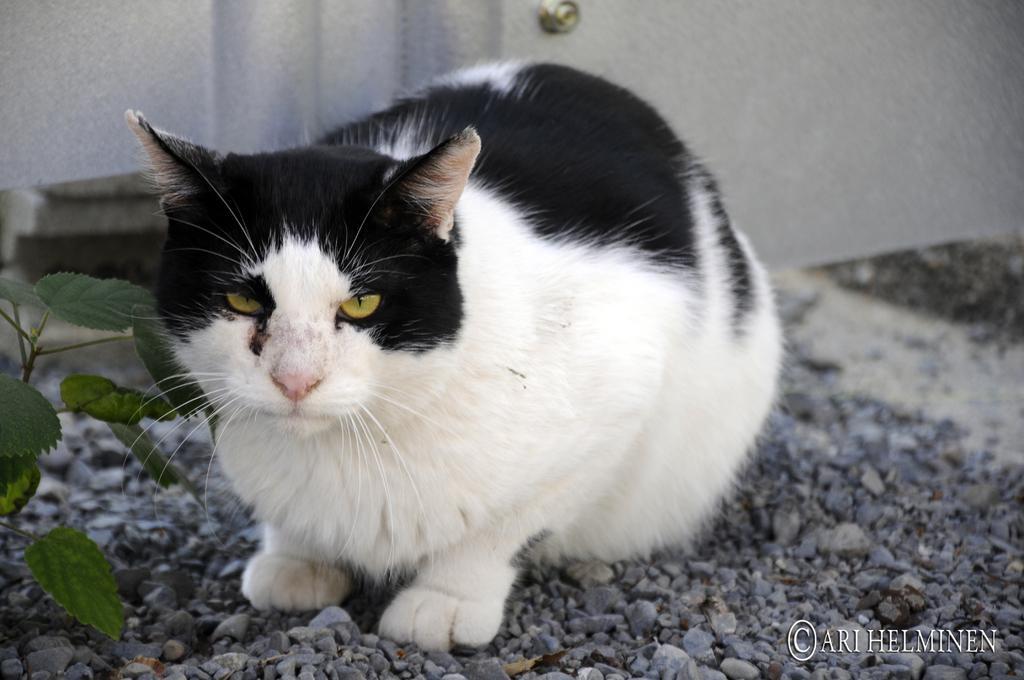Could you give a brief overview of what you see in this image? This image is taken outdoors. At the bottom of the image there is a ground with pebbles on it. On the left side of the image there is a plant. In the background there is a wall. In the middle of the image there is a cat on the ground. 